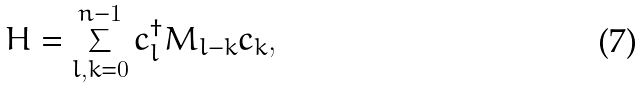Convert formula to latex. <formula><loc_0><loc_0><loc_500><loc_500>H = \sum _ { l , k = 0 } ^ { n - 1 } c _ { l } ^ { \dagger } M _ { l - k } c _ { k } ,</formula> 